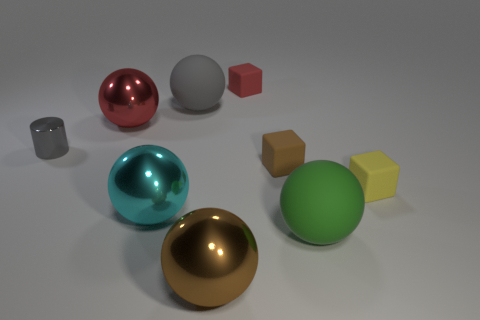What number of objects are either rubber spheres that are to the right of the red matte object or objects that are on the left side of the gray ball?
Ensure brevity in your answer.  4. There is a large object that is in front of the matte sphere that is in front of the cylinder; what is its color?
Provide a short and direct response. Brown. The tiny cylinder that is made of the same material as the cyan thing is what color?
Provide a short and direct response. Gray. How many large things are the same color as the small cylinder?
Your response must be concise. 1. What number of objects are either gray metal things or brown shiny spheres?
Give a very brief answer. 2. The gray metallic object that is the same size as the yellow rubber cube is what shape?
Provide a short and direct response. Cylinder. What number of tiny matte cubes are both to the left of the big green ball and on the right side of the tiny red matte object?
Offer a terse response. 1. What material is the gray object behind the red metal sphere?
Make the answer very short. Rubber. What size is the red thing that is the same material as the small brown thing?
Offer a very short reply. Small. Do the brown object behind the tiny yellow rubber object and the green rubber sphere to the right of the tiny gray object have the same size?
Offer a terse response. No. 